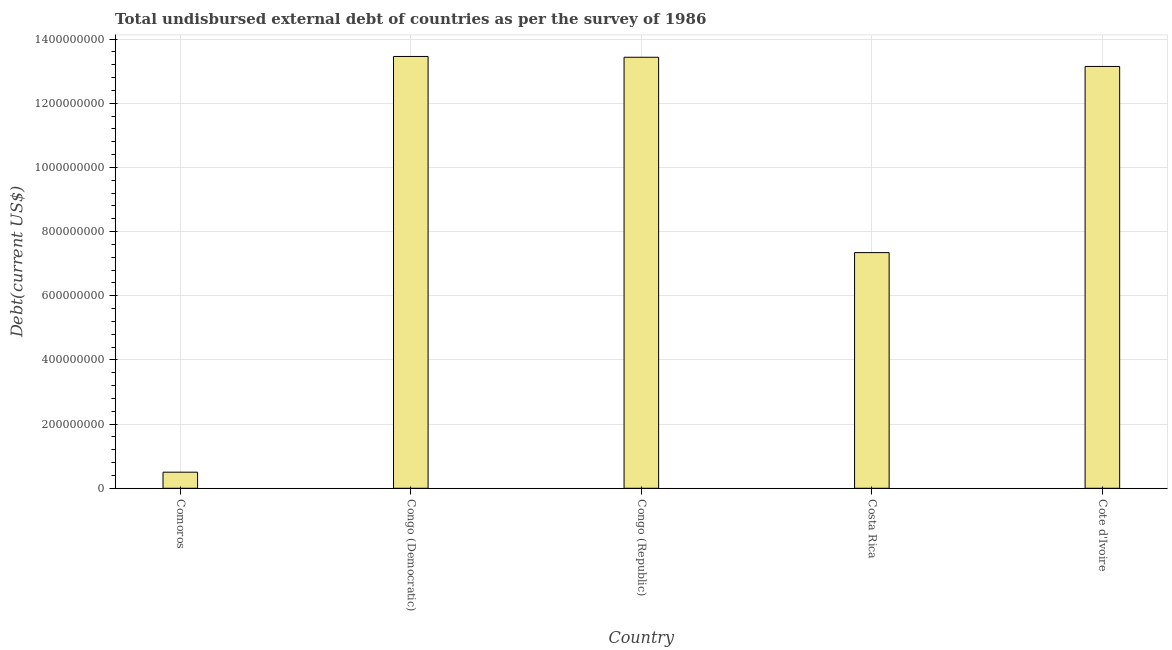Does the graph contain any zero values?
Provide a succinct answer. No. Does the graph contain grids?
Offer a very short reply. Yes. What is the title of the graph?
Provide a succinct answer. Total undisbursed external debt of countries as per the survey of 1986. What is the label or title of the Y-axis?
Your response must be concise. Debt(current US$). What is the total debt in Comoros?
Provide a short and direct response. 5.02e+07. Across all countries, what is the maximum total debt?
Your answer should be compact. 1.35e+09. Across all countries, what is the minimum total debt?
Provide a short and direct response. 5.02e+07. In which country was the total debt maximum?
Your answer should be very brief. Congo (Democratic). In which country was the total debt minimum?
Ensure brevity in your answer.  Comoros. What is the sum of the total debt?
Your answer should be very brief. 4.79e+09. What is the difference between the total debt in Congo (Republic) and Costa Rica?
Offer a terse response. 6.09e+08. What is the average total debt per country?
Your response must be concise. 9.58e+08. What is the median total debt?
Your answer should be compact. 1.31e+09. In how many countries, is the total debt greater than 920000000 US$?
Give a very brief answer. 3. What is the ratio of the total debt in Comoros to that in Costa Rica?
Ensure brevity in your answer.  0.07. Is the difference between the total debt in Comoros and Congo (Democratic) greater than the difference between any two countries?
Give a very brief answer. Yes. What is the difference between the highest and the second highest total debt?
Ensure brevity in your answer.  2.46e+06. Is the sum of the total debt in Comoros and Congo (Democratic) greater than the maximum total debt across all countries?
Ensure brevity in your answer.  Yes. What is the difference between the highest and the lowest total debt?
Provide a short and direct response. 1.30e+09. Are the values on the major ticks of Y-axis written in scientific E-notation?
Make the answer very short. No. What is the Debt(current US$) of Comoros?
Offer a terse response. 5.02e+07. What is the Debt(current US$) of Congo (Democratic)?
Your answer should be compact. 1.35e+09. What is the Debt(current US$) in Congo (Republic)?
Your answer should be compact. 1.34e+09. What is the Debt(current US$) of Costa Rica?
Offer a very short reply. 7.34e+08. What is the Debt(current US$) in Cote d'Ivoire?
Keep it short and to the point. 1.31e+09. What is the difference between the Debt(current US$) in Comoros and Congo (Democratic)?
Your answer should be compact. -1.30e+09. What is the difference between the Debt(current US$) in Comoros and Congo (Republic)?
Give a very brief answer. -1.29e+09. What is the difference between the Debt(current US$) in Comoros and Costa Rica?
Keep it short and to the point. -6.84e+08. What is the difference between the Debt(current US$) in Comoros and Cote d'Ivoire?
Give a very brief answer. -1.26e+09. What is the difference between the Debt(current US$) in Congo (Democratic) and Congo (Republic)?
Your answer should be compact. 2.46e+06. What is the difference between the Debt(current US$) in Congo (Democratic) and Costa Rica?
Provide a succinct answer. 6.11e+08. What is the difference between the Debt(current US$) in Congo (Democratic) and Cote d'Ivoire?
Make the answer very short. 3.11e+07. What is the difference between the Debt(current US$) in Congo (Republic) and Costa Rica?
Ensure brevity in your answer.  6.09e+08. What is the difference between the Debt(current US$) in Congo (Republic) and Cote d'Ivoire?
Your answer should be compact. 2.86e+07. What is the difference between the Debt(current US$) in Costa Rica and Cote d'Ivoire?
Provide a succinct answer. -5.80e+08. What is the ratio of the Debt(current US$) in Comoros to that in Congo (Democratic)?
Offer a very short reply. 0.04. What is the ratio of the Debt(current US$) in Comoros to that in Congo (Republic)?
Keep it short and to the point. 0.04. What is the ratio of the Debt(current US$) in Comoros to that in Costa Rica?
Your response must be concise. 0.07. What is the ratio of the Debt(current US$) in Comoros to that in Cote d'Ivoire?
Ensure brevity in your answer.  0.04. What is the ratio of the Debt(current US$) in Congo (Democratic) to that in Congo (Republic)?
Ensure brevity in your answer.  1. What is the ratio of the Debt(current US$) in Congo (Democratic) to that in Costa Rica?
Provide a succinct answer. 1.83. What is the ratio of the Debt(current US$) in Congo (Democratic) to that in Cote d'Ivoire?
Provide a short and direct response. 1.02. What is the ratio of the Debt(current US$) in Congo (Republic) to that in Costa Rica?
Your response must be concise. 1.83. What is the ratio of the Debt(current US$) in Congo (Republic) to that in Cote d'Ivoire?
Give a very brief answer. 1.02. What is the ratio of the Debt(current US$) in Costa Rica to that in Cote d'Ivoire?
Make the answer very short. 0.56. 